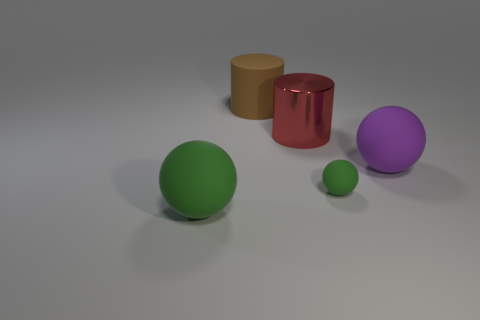Subtract all small rubber balls. How many balls are left? 2 Subtract all yellow cylinders. How many green spheres are left? 2 Add 2 tiny yellow metallic blocks. How many objects exist? 7 Subtract all spheres. How many objects are left? 2 Add 2 metal cylinders. How many metal cylinders exist? 3 Subtract 1 red cylinders. How many objects are left? 4 Subtract all red balls. Subtract all gray cubes. How many balls are left? 3 Subtract all red cylinders. Subtract all small cyan shiny cylinders. How many objects are left? 4 Add 1 small green objects. How many small green objects are left? 2 